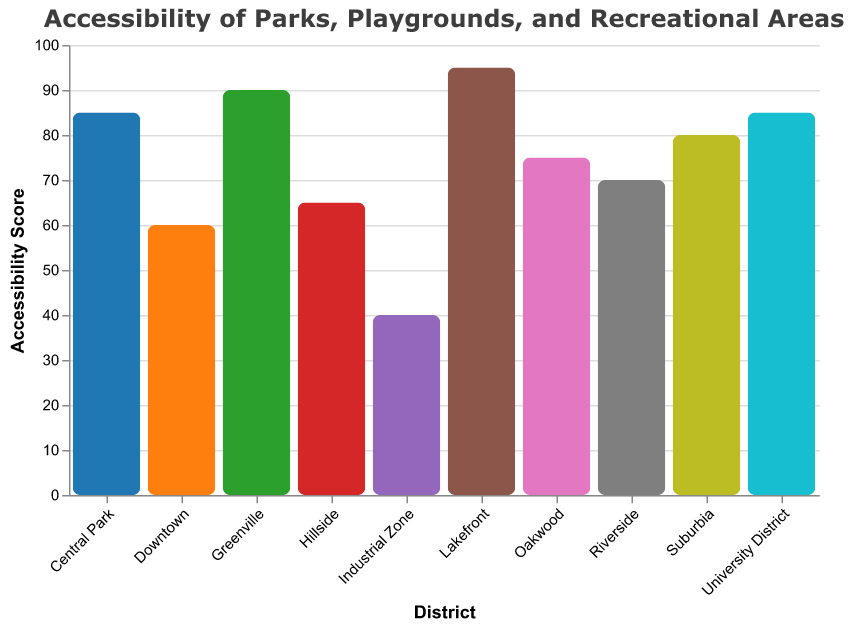What is the title of the figure? The title can be found at the top of the figure, it reads "Accessibility of Parks, Playgrounds, and Recreational Areas".
Answer: Accessibility of Parks, Playgrounds, and Recreational Areas Which district has the highest park accessibility score? By inspecting the vertical bar heights, Lakefront has the tallest bar with a score of 95 in park accessibility.
Answer: Lakefront What is the range of the y-axis? The y-axis range is determined by the smallest and largest values in the data, which span from 0 to 100.
Answer: 0 to 100 How many districts have a park accessibility score of 85 or higher? The districts with scores 85 or higher are Central Park, Greenville, Lakefront, and University District. Counting them gives a total of 4 districts.
Answer: 4 Which district has the lowest recreational area accessibility score? By comparing the heights of the bars indicating recreational area accessibility, Downtown has the lowest score at 50.
Answer: Downtown What is the average park accessibility score across all districts? Sum the scores of all districts (85+70+60+80+75+90+40+65+95+85) which is 745, then divide by the number of districts, which is 10. The average is 74.5.
Answer: 74.5 Compare the playground accessibility scores of Riverside and Suburbia. Which is higher and by how much? Riverside has a playground accessibility score of 75, and Suburbia has a score of 85. Suburbia's score is higher by 10 points.
Answer: Suburbia by 10 points Which district has the smallest difference between park accessibility and playground accessibility scores? Calculate the difference for each district and find the smallest: Central Park (5), Riverside (5), Downtown (5), Suburbia (5), Oakwood (5), Greenville (5), Industrial Zone (5), Hillside (5), Lakefront (5), University District (5). All have the same difference of 5.
Answer: All districts with a difference of 5 Is there a district where the park and playground accessibility scores are equal? By examining the values, none of the districts have equal scores for park and playground accessibility.
Answer: No Which accessibility type has the highest average score across all districts: park, playground, or recreational area? Calculate the average for each type: 
Park: (745/10 = 74.5)
Playground: (750/10 = 75)
Recreational Area: (690/10 = 69)
Playground accessibility has the highest average score.
Answer: Playground 